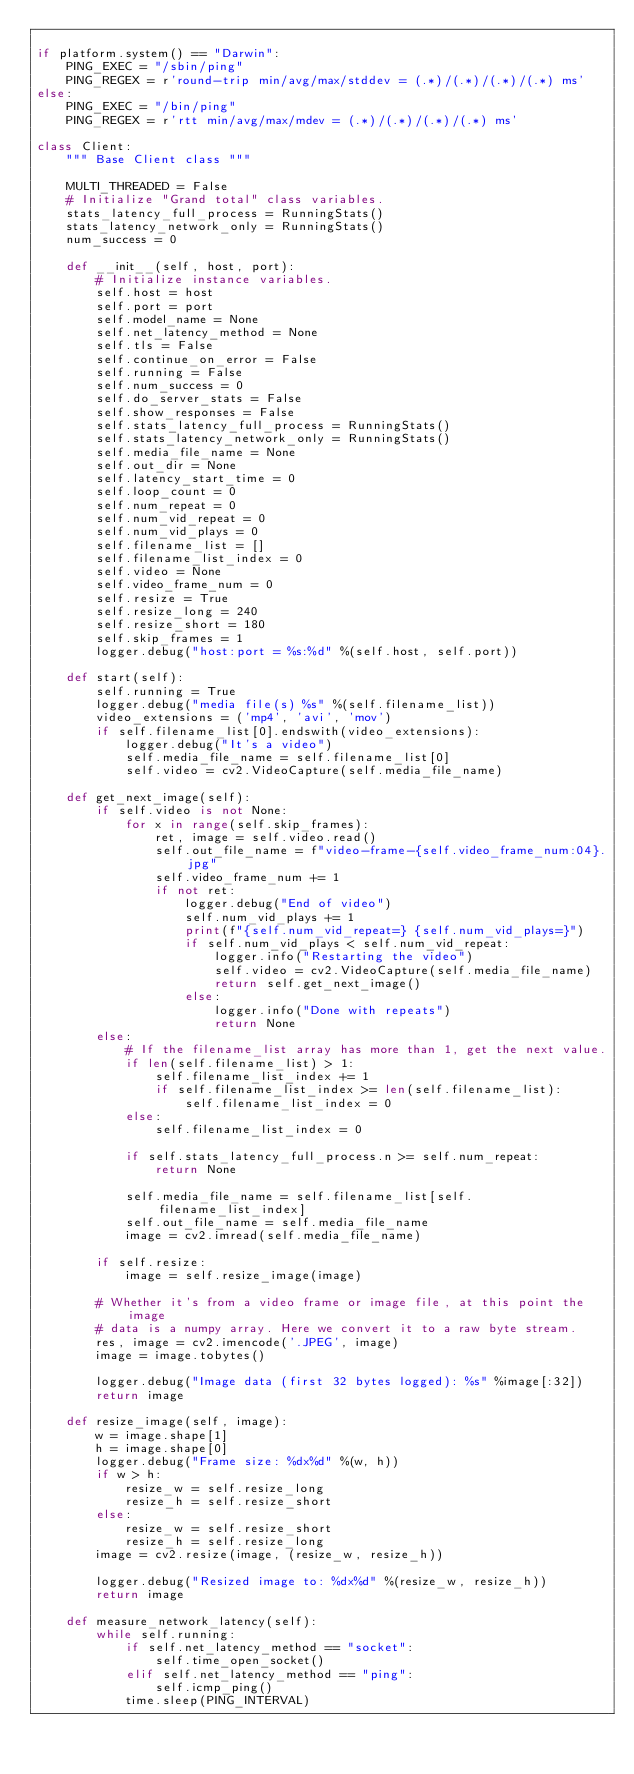Convert code to text. <code><loc_0><loc_0><loc_500><loc_500><_Python_>
if platform.system() == "Darwin":
    PING_EXEC = "/sbin/ping"
    PING_REGEX = r'round-trip min/avg/max/stddev = (.*)/(.*)/(.*)/(.*) ms'
else:
    PING_EXEC = "/bin/ping"
    PING_REGEX = r'rtt min/avg/max/mdev = (.*)/(.*)/(.*)/(.*) ms'

class Client:
    """ Base Client class """

    MULTI_THREADED = False
    # Initialize "Grand total" class variables.
    stats_latency_full_process = RunningStats()
    stats_latency_network_only = RunningStats()
    num_success = 0

    def __init__(self, host, port):
        # Initialize instance variables.
        self.host = host
        self.port = port
        self.model_name = None
        self.net_latency_method = None
        self.tls = False
        self.continue_on_error = False
        self.running = False
        self.num_success = 0
        self.do_server_stats = False
        self.show_responses = False
        self.stats_latency_full_process = RunningStats()
        self.stats_latency_network_only = RunningStats()
        self.media_file_name = None
        self.out_dir = None
        self.latency_start_time = 0
        self.loop_count = 0
        self.num_repeat = 0
        self.num_vid_repeat = 0
        self.num_vid_plays = 0
        self.filename_list = []
        self.filename_list_index = 0
        self.video = None
        self.video_frame_num = 0
        self.resize = True
        self.resize_long = 240
        self.resize_short = 180
        self.skip_frames = 1
        logger.debug("host:port = %s:%d" %(self.host, self.port))

    def start(self):
        self.running = True
        logger.debug("media file(s) %s" %(self.filename_list))
        video_extensions = ('mp4', 'avi', 'mov')
        if self.filename_list[0].endswith(video_extensions):
            logger.debug("It's a video")
            self.media_file_name = self.filename_list[0]
            self.video = cv2.VideoCapture(self.media_file_name)

    def get_next_image(self):
        if self.video is not None:
            for x in range(self.skip_frames):
                ret, image = self.video.read()
                self.out_file_name = f"video-frame-{self.video_frame_num:04}.jpg"
                self.video_frame_num += 1
                if not ret:
                    logger.debug("End of video")
                    self.num_vid_plays += 1
                    print(f"{self.num_vid_repeat=} {self.num_vid_plays=}")
                    if self.num_vid_plays < self.num_vid_repeat:
                        logger.info("Restarting the video")
                        self.video = cv2.VideoCapture(self.media_file_name)
                        return self.get_next_image()
                    else:
                        logger.info("Done with repeats")
                        return None
        else:
            # If the filename_list array has more than 1, get the next value.
            if len(self.filename_list) > 1:
                self.filename_list_index += 1
                if self.filename_list_index >= len(self.filename_list):
                    self.filename_list_index = 0
            else:
                self.filename_list_index = 0

            if self.stats_latency_full_process.n >= self.num_repeat:
                return None

            self.media_file_name = self.filename_list[self.filename_list_index]
            self.out_file_name = self.media_file_name
            image = cv2.imread(self.media_file_name)

        if self.resize:
            image = self.resize_image(image)

        # Whether it's from a video frame or image file, at this point the image
        # data is a numpy array. Here we convert it to a raw byte stream.
        res, image = cv2.imencode('.JPEG', image)
        image = image.tobytes()

        logger.debug("Image data (first 32 bytes logged): %s" %image[:32])
        return image

    def resize_image(self, image):
        w = image.shape[1]
        h = image.shape[0]
        logger.debug("Frame size: %dx%d" %(w, h))
        if w > h:
            resize_w = self.resize_long
            resize_h = self.resize_short
        else:
            resize_w = self.resize_short
            resize_h = self.resize_long
        image = cv2.resize(image, (resize_w, resize_h))

        logger.debug("Resized image to: %dx%d" %(resize_w, resize_h))
        return image

    def measure_network_latency(self):
        while self.running:
            if self.net_latency_method == "socket":
                self.time_open_socket()
            elif self.net_latency_method == "ping":
                self.icmp_ping()
            time.sleep(PING_INTERVAL)
</code> 